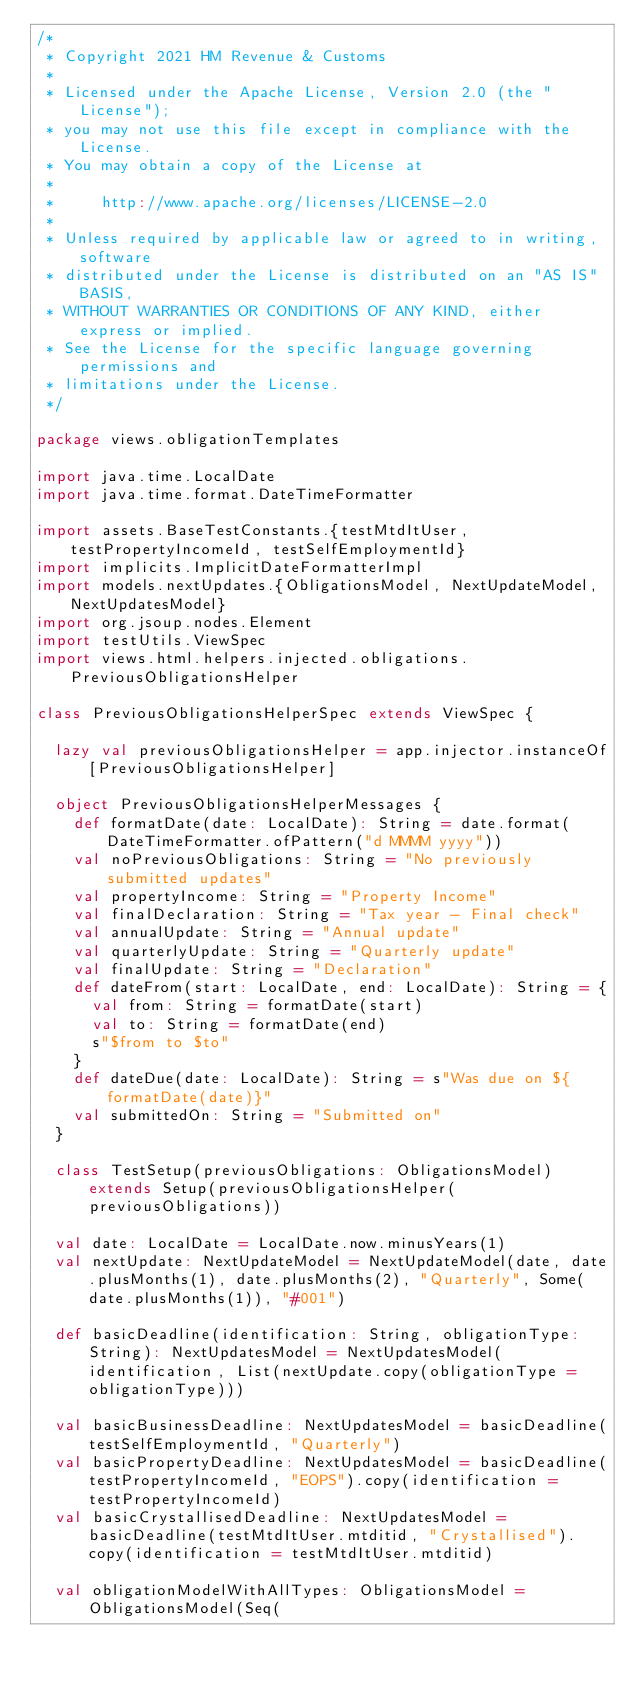<code> <loc_0><loc_0><loc_500><loc_500><_Scala_>/*
 * Copyright 2021 HM Revenue & Customs
 *
 * Licensed under the Apache License, Version 2.0 (the "License");
 * you may not use this file except in compliance with the License.
 * You may obtain a copy of the License at
 *
 *     http://www.apache.org/licenses/LICENSE-2.0
 *
 * Unless required by applicable law or agreed to in writing, software
 * distributed under the License is distributed on an "AS IS" BASIS,
 * WITHOUT WARRANTIES OR CONDITIONS OF ANY KIND, either express or implied.
 * See the License for the specific language governing permissions and
 * limitations under the License.
 */

package views.obligationTemplates

import java.time.LocalDate
import java.time.format.DateTimeFormatter

import assets.BaseTestConstants.{testMtdItUser, testPropertyIncomeId, testSelfEmploymentId}
import implicits.ImplicitDateFormatterImpl
import models.nextUpdates.{ObligationsModel, NextUpdateModel, NextUpdatesModel}
import org.jsoup.nodes.Element
import testUtils.ViewSpec
import views.html.helpers.injected.obligations.PreviousObligationsHelper

class PreviousObligationsHelperSpec extends ViewSpec {

  lazy val previousObligationsHelper = app.injector.instanceOf[PreviousObligationsHelper]

  object PreviousObligationsHelperMessages {
    def formatDate(date: LocalDate): String = date.format(DateTimeFormatter.ofPattern("d MMMM yyyy"))
    val noPreviousObligations: String = "No previously submitted updates"
    val propertyIncome: String = "Property Income"
    val finalDeclaration: String = "Tax year - Final check"
    val annualUpdate: String = "Annual update"
    val quarterlyUpdate: String = "Quarterly update"
    val finalUpdate: String = "Declaration"
    def dateFrom(start: LocalDate, end: LocalDate): String = {
      val from: String = formatDate(start)
      val to: String = formatDate(end)
      s"$from to $to"
    }
    def dateDue(date: LocalDate): String = s"Was due on ${formatDate(date)}"
    val submittedOn: String = "Submitted on"
  }

  class TestSetup(previousObligations: ObligationsModel) extends Setup(previousObligationsHelper(previousObligations))

  val date: LocalDate = LocalDate.now.minusYears(1)
  val nextUpdate: NextUpdateModel = NextUpdateModel(date, date.plusMonths(1), date.plusMonths(2), "Quarterly", Some(date.plusMonths(1)), "#001")

  def basicDeadline(identification: String, obligationType: String): NextUpdatesModel = NextUpdatesModel(identification, List(nextUpdate.copy(obligationType = obligationType)))

  val basicBusinessDeadline: NextUpdatesModel = basicDeadline(testSelfEmploymentId, "Quarterly")
  val basicPropertyDeadline: NextUpdatesModel = basicDeadline(testPropertyIncomeId, "EOPS").copy(identification = testPropertyIncomeId)
  val basicCrystallisedDeadline: NextUpdatesModel = basicDeadline(testMtdItUser.mtditid, "Crystallised").copy(identification = testMtdItUser.mtditid)

  val obligationModelWithAllTypes: ObligationsModel = ObligationsModel(Seq(</code> 